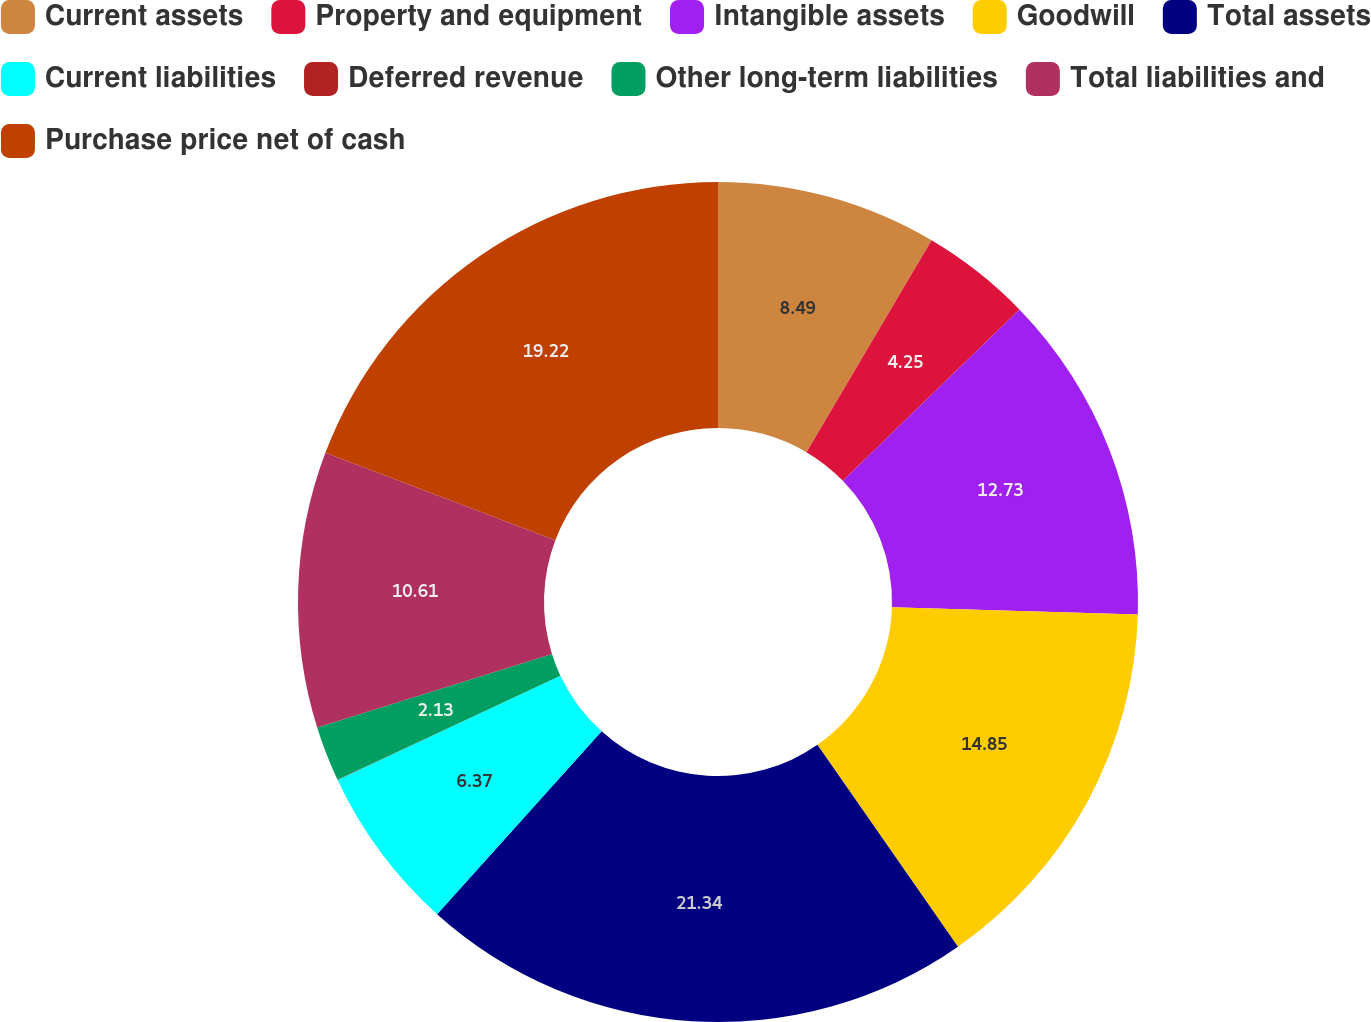Convert chart to OTSL. <chart><loc_0><loc_0><loc_500><loc_500><pie_chart><fcel>Current assets<fcel>Property and equipment<fcel>Intangible assets<fcel>Goodwill<fcel>Total assets<fcel>Current liabilities<fcel>Deferred revenue<fcel>Other long-term liabilities<fcel>Total liabilities and<fcel>Purchase price net of cash<nl><fcel>8.49%<fcel>4.25%<fcel>12.73%<fcel>14.85%<fcel>21.34%<fcel>6.37%<fcel>0.01%<fcel>2.13%<fcel>10.61%<fcel>19.22%<nl></chart> 